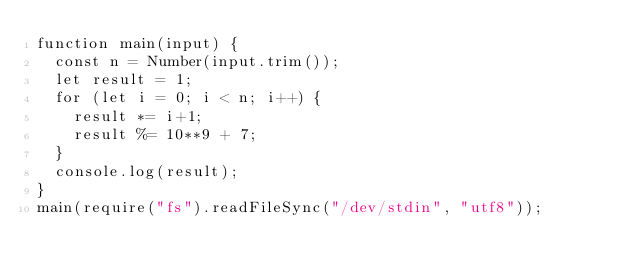<code> <loc_0><loc_0><loc_500><loc_500><_TypeScript_>function main(input) {
  const n = Number(input.trim());
  let result = 1;
  for (let i = 0; i < n; i++) {
    result *= i+1;
    result %= 10**9 + 7;
  }
  console.log(result);
}
main(require("fs").readFileSync("/dev/stdin", "utf8"));</code> 